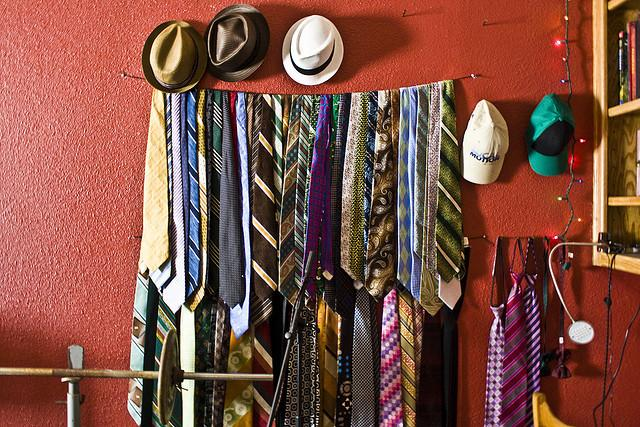Who does this room belong to? Please explain your reasoning. man. The room belongs to a man. 